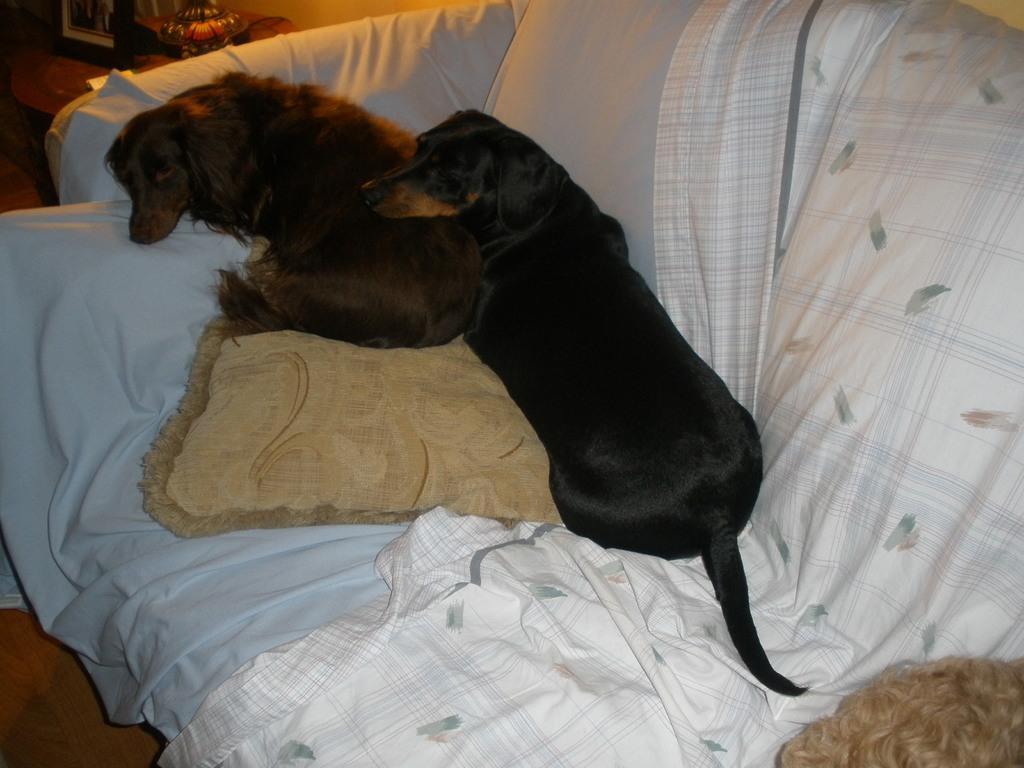Could you give a brief overview of what you see in this image? In this picture we can see two dogs on a couch, where we can see a pillow, clothes and in the background we can see a photo frame and some objects. 